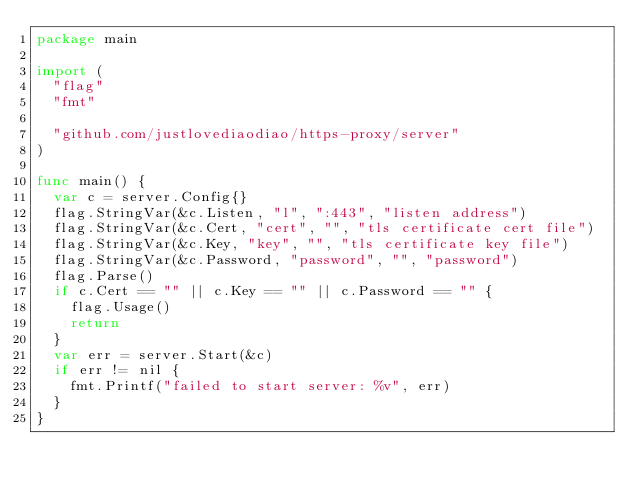Convert code to text. <code><loc_0><loc_0><loc_500><loc_500><_Go_>package main

import (
	"flag"
	"fmt"

	"github.com/justlovediaodiao/https-proxy/server"
)

func main() {
	var c = server.Config{}
	flag.StringVar(&c.Listen, "l", ":443", "listen address")
	flag.StringVar(&c.Cert, "cert", "", "tls certificate cert file")
	flag.StringVar(&c.Key, "key", "", "tls certificate key file")
	flag.StringVar(&c.Password, "password", "", "password")
	flag.Parse()
	if c.Cert == "" || c.Key == "" || c.Password == "" {
		flag.Usage()
		return
	}
	var err = server.Start(&c)
	if err != nil {
		fmt.Printf("failed to start server: %v", err)
	}
}
</code> 